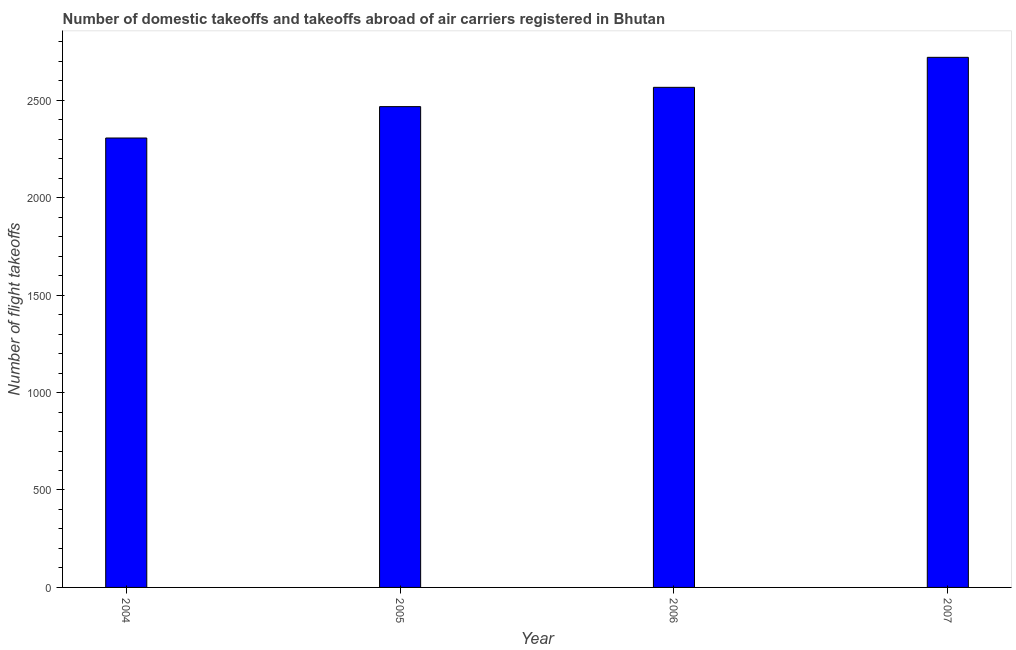Does the graph contain any zero values?
Provide a short and direct response. No. Does the graph contain grids?
Your answer should be very brief. No. What is the title of the graph?
Ensure brevity in your answer.  Number of domestic takeoffs and takeoffs abroad of air carriers registered in Bhutan. What is the label or title of the X-axis?
Give a very brief answer. Year. What is the label or title of the Y-axis?
Ensure brevity in your answer.  Number of flight takeoffs. What is the number of flight takeoffs in 2005?
Keep it short and to the point. 2467. Across all years, what is the maximum number of flight takeoffs?
Give a very brief answer. 2720. Across all years, what is the minimum number of flight takeoffs?
Ensure brevity in your answer.  2306. In which year was the number of flight takeoffs maximum?
Your answer should be very brief. 2007. In which year was the number of flight takeoffs minimum?
Make the answer very short. 2004. What is the sum of the number of flight takeoffs?
Keep it short and to the point. 1.01e+04. What is the difference between the number of flight takeoffs in 2005 and 2007?
Ensure brevity in your answer.  -253. What is the average number of flight takeoffs per year?
Give a very brief answer. 2514.75. What is the median number of flight takeoffs?
Provide a short and direct response. 2516.5. What is the ratio of the number of flight takeoffs in 2005 to that in 2007?
Your answer should be compact. 0.91. Is the number of flight takeoffs in 2006 less than that in 2007?
Provide a succinct answer. Yes. What is the difference between the highest and the second highest number of flight takeoffs?
Your answer should be very brief. 154. Is the sum of the number of flight takeoffs in 2005 and 2007 greater than the maximum number of flight takeoffs across all years?
Your response must be concise. Yes. What is the difference between the highest and the lowest number of flight takeoffs?
Provide a succinct answer. 414. In how many years, is the number of flight takeoffs greater than the average number of flight takeoffs taken over all years?
Your answer should be compact. 2. Are all the bars in the graph horizontal?
Your answer should be compact. No. What is the difference between two consecutive major ticks on the Y-axis?
Give a very brief answer. 500. Are the values on the major ticks of Y-axis written in scientific E-notation?
Provide a short and direct response. No. What is the Number of flight takeoffs of 2004?
Offer a very short reply. 2306. What is the Number of flight takeoffs in 2005?
Your answer should be very brief. 2467. What is the Number of flight takeoffs in 2006?
Your response must be concise. 2566. What is the Number of flight takeoffs in 2007?
Your answer should be compact. 2720. What is the difference between the Number of flight takeoffs in 2004 and 2005?
Provide a succinct answer. -161. What is the difference between the Number of flight takeoffs in 2004 and 2006?
Make the answer very short. -260. What is the difference between the Number of flight takeoffs in 2004 and 2007?
Offer a very short reply. -414. What is the difference between the Number of flight takeoffs in 2005 and 2006?
Ensure brevity in your answer.  -99. What is the difference between the Number of flight takeoffs in 2005 and 2007?
Your response must be concise. -253. What is the difference between the Number of flight takeoffs in 2006 and 2007?
Give a very brief answer. -154. What is the ratio of the Number of flight takeoffs in 2004 to that in 2005?
Ensure brevity in your answer.  0.94. What is the ratio of the Number of flight takeoffs in 2004 to that in 2006?
Your response must be concise. 0.9. What is the ratio of the Number of flight takeoffs in 2004 to that in 2007?
Give a very brief answer. 0.85. What is the ratio of the Number of flight takeoffs in 2005 to that in 2007?
Your response must be concise. 0.91. What is the ratio of the Number of flight takeoffs in 2006 to that in 2007?
Offer a very short reply. 0.94. 